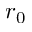<formula> <loc_0><loc_0><loc_500><loc_500>r _ { 0 }</formula> 